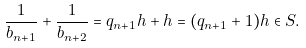<formula> <loc_0><loc_0><loc_500><loc_500>\frac { 1 } { b _ { n + 1 } } + \frac { 1 } { b _ { n + 2 } } = q _ { n + 1 } h + h = ( q _ { n + 1 } + 1 ) h \in S .</formula> 